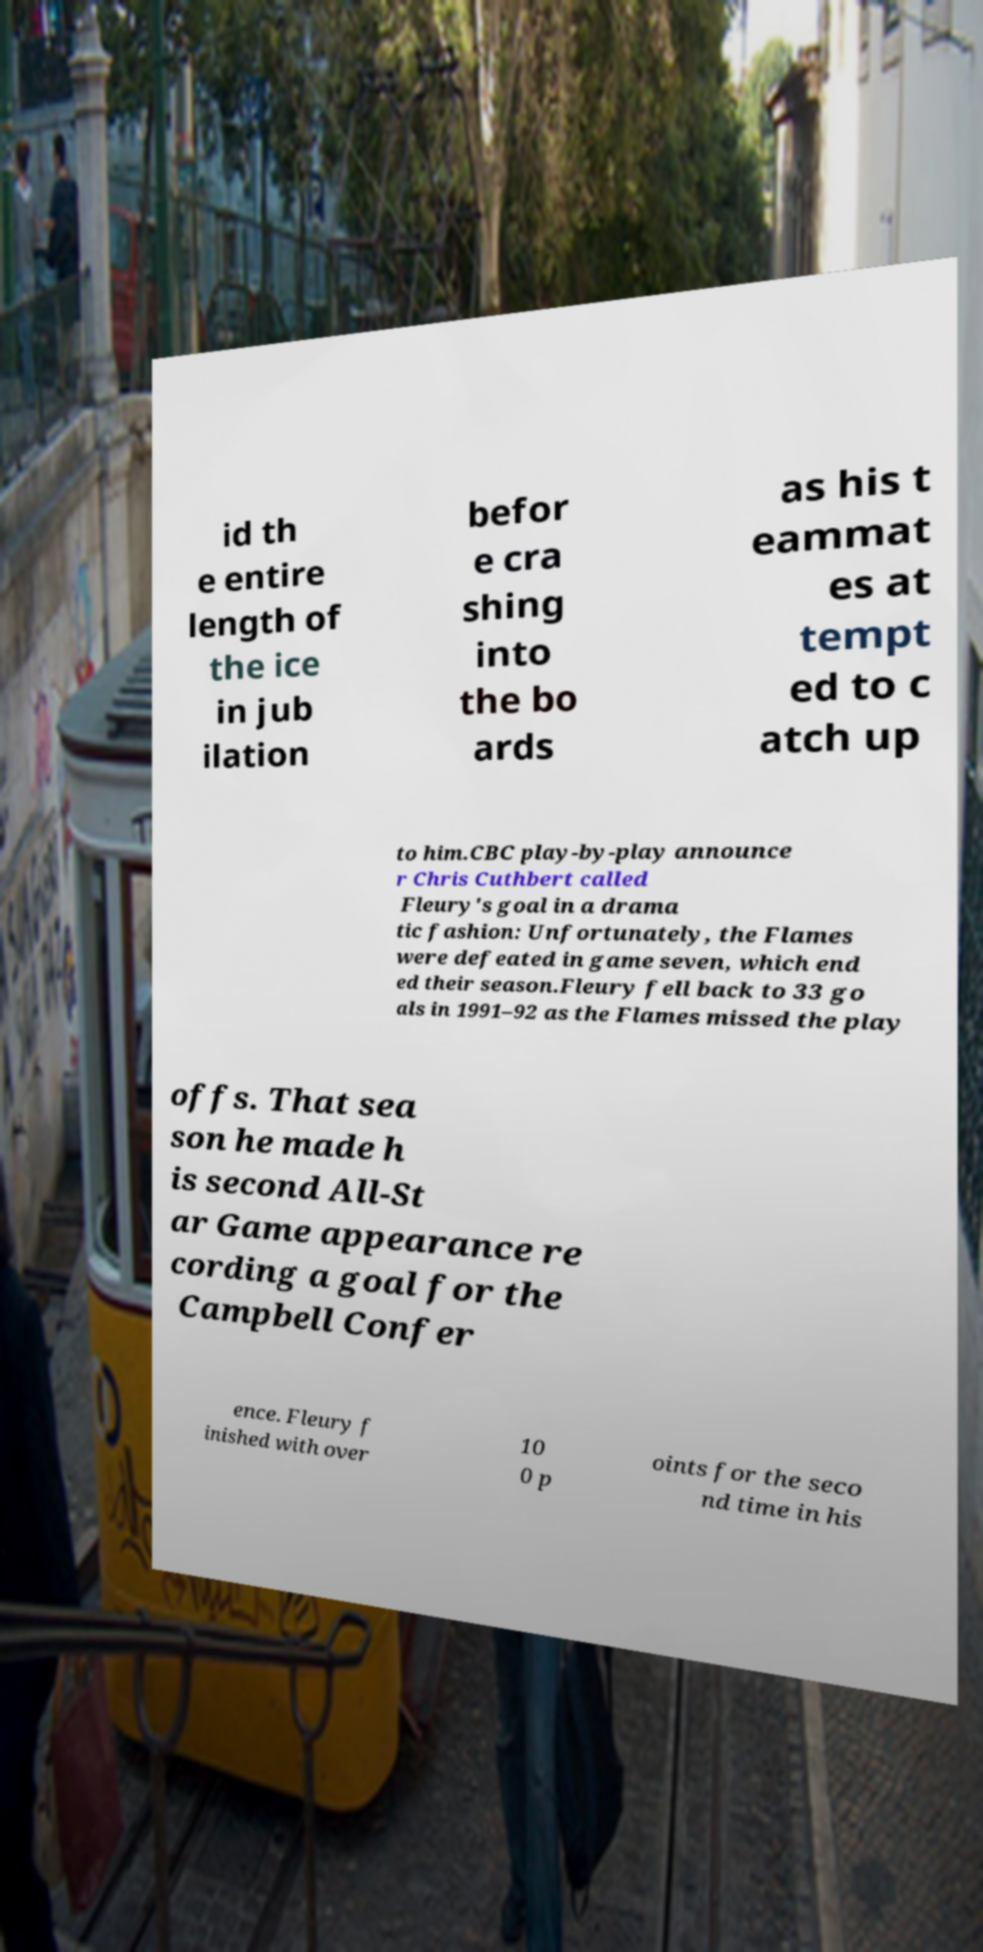What messages or text are displayed in this image? I need them in a readable, typed format. id th e entire length of the ice in jub ilation befor e cra shing into the bo ards as his t eammat es at tempt ed to c atch up to him.CBC play-by-play announce r Chris Cuthbert called Fleury's goal in a drama tic fashion: Unfortunately, the Flames were defeated in game seven, which end ed their season.Fleury fell back to 33 go als in 1991–92 as the Flames missed the play offs. That sea son he made h is second All-St ar Game appearance re cording a goal for the Campbell Confer ence. Fleury f inished with over 10 0 p oints for the seco nd time in his 